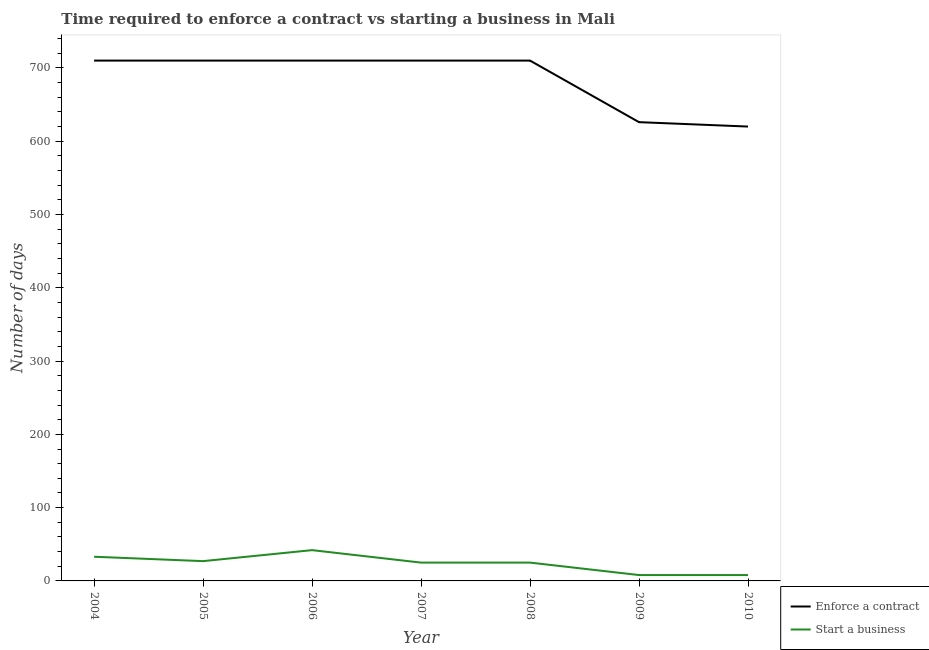Across all years, what is the maximum number of days to start a business?
Give a very brief answer. 42. In which year was the number of days to enforece a contract maximum?
Provide a succinct answer. 2004. In which year was the number of days to enforece a contract minimum?
Make the answer very short. 2010. What is the total number of days to start a business in the graph?
Your answer should be compact. 168. What is the difference between the number of days to start a business in 2004 and that in 2005?
Offer a terse response. 6. What is the difference between the number of days to start a business in 2005 and the number of days to enforece a contract in 2008?
Your response must be concise. -683. What is the average number of days to enforece a contract per year?
Offer a terse response. 685.14. In the year 2007, what is the difference between the number of days to start a business and number of days to enforece a contract?
Make the answer very short. -685. In how many years, is the number of days to enforece a contract greater than 360 days?
Keep it short and to the point. 7. What is the difference between the highest and the second highest number of days to enforece a contract?
Your response must be concise. 0. What is the difference between the highest and the lowest number of days to enforece a contract?
Offer a very short reply. 90. In how many years, is the number of days to enforece a contract greater than the average number of days to enforece a contract taken over all years?
Keep it short and to the point. 5. Is the number of days to start a business strictly greater than the number of days to enforece a contract over the years?
Provide a short and direct response. No. Is the number of days to start a business strictly less than the number of days to enforece a contract over the years?
Ensure brevity in your answer.  Yes. How many lines are there?
Your answer should be compact. 2. How many years are there in the graph?
Your response must be concise. 7. What is the difference between two consecutive major ticks on the Y-axis?
Your response must be concise. 100. Does the graph contain any zero values?
Ensure brevity in your answer.  No. How many legend labels are there?
Offer a very short reply. 2. How are the legend labels stacked?
Make the answer very short. Vertical. What is the title of the graph?
Your answer should be very brief. Time required to enforce a contract vs starting a business in Mali. What is the label or title of the X-axis?
Offer a very short reply. Year. What is the label or title of the Y-axis?
Ensure brevity in your answer.  Number of days. What is the Number of days of Enforce a contract in 2004?
Ensure brevity in your answer.  710. What is the Number of days of Enforce a contract in 2005?
Your answer should be very brief. 710. What is the Number of days of Start a business in 2005?
Offer a terse response. 27. What is the Number of days in Enforce a contract in 2006?
Provide a short and direct response. 710. What is the Number of days in Start a business in 2006?
Offer a terse response. 42. What is the Number of days in Enforce a contract in 2007?
Offer a very short reply. 710. What is the Number of days of Enforce a contract in 2008?
Provide a short and direct response. 710. What is the Number of days in Start a business in 2008?
Give a very brief answer. 25. What is the Number of days of Enforce a contract in 2009?
Provide a succinct answer. 626. What is the Number of days in Enforce a contract in 2010?
Provide a short and direct response. 620. What is the Number of days of Start a business in 2010?
Give a very brief answer. 8. Across all years, what is the maximum Number of days of Enforce a contract?
Ensure brevity in your answer.  710. Across all years, what is the maximum Number of days of Start a business?
Your answer should be compact. 42. Across all years, what is the minimum Number of days of Enforce a contract?
Ensure brevity in your answer.  620. What is the total Number of days in Enforce a contract in the graph?
Provide a short and direct response. 4796. What is the total Number of days of Start a business in the graph?
Keep it short and to the point. 168. What is the difference between the Number of days of Enforce a contract in 2004 and that in 2006?
Offer a terse response. 0. What is the difference between the Number of days in Start a business in 2004 and that in 2007?
Make the answer very short. 8. What is the difference between the Number of days in Start a business in 2004 and that in 2008?
Provide a succinct answer. 8. What is the difference between the Number of days in Enforce a contract in 2004 and that in 2009?
Give a very brief answer. 84. What is the difference between the Number of days in Start a business in 2004 and that in 2009?
Your answer should be compact. 25. What is the difference between the Number of days in Enforce a contract in 2004 and that in 2010?
Your answer should be compact. 90. What is the difference between the Number of days in Enforce a contract in 2005 and that in 2006?
Provide a succinct answer. 0. What is the difference between the Number of days of Start a business in 2005 and that in 2007?
Your answer should be compact. 2. What is the difference between the Number of days in Enforce a contract in 2005 and that in 2008?
Provide a succinct answer. 0. What is the difference between the Number of days in Start a business in 2005 and that in 2008?
Provide a short and direct response. 2. What is the difference between the Number of days of Start a business in 2005 and that in 2009?
Give a very brief answer. 19. What is the difference between the Number of days in Enforce a contract in 2006 and that in 2008?
Provide a succinct answer. 0. What is the difference between the Number of days of Start a business in 2006 and that in 2008?
Your answer should be compact. 17. What is the difference between the Number of days of Enforce a contract in 2006 and that in 2009?
Make the answer very short. 84. What is the difference between the Number of days of Enforce a contract in 2006 and that in 2010?
Your answer should be compact. 90. What is the difference between the Number of days of Enforce a contract in 2007 and that in 2008?
Offer a very short reply. 0. What is the difference between the Number of days in Start a business in 2007 and that in 2009?
Give a very brief answer. 17. What is the difference between the Number of days in Enforce a contract in 2007 and that in 2010?
Your answer should be compact. 90. What is the difference between the Number of days in Start a business in 2007 and that in 2010?
Provide a short and direct response. 17. What is the difference between the Number of days in Start a business in 2008 and that in 2009?
Offer a terse response. 17. What is the difference between the Number of days of Start a business in 2008 and that in 2010?
Make the answer very short. 17. What is the difference between the Number of days in Enforce a contract in 2004 and the Number of days in Start a business in 2005?
Your answer should be compact. 683. What is the difference between the Number of days in Enforce a contract in 2004 and the Number of days in Start a business in 2006?
Offer a terse response. 668. What is the difference between the Number of days of Enforce a contract in 2004 and the Number of days of Start a business in 2007?
Your answer should be very brief. 685. What is the difference between the Number of days of Enforce a contract in 2004 and the Number of days of Start a business in 2008?
Your response must be concise. 685. What is the difference between the Number of days of Enforce a contract in 2004 and the Number of days of Start a business in 2009?
Give a very brief answer. 702. What is the difference between the Number of days of Enforce a contract in 2004 and the Number of days of Start a business in 2010?
Ensure brevity in your answer.  702. What is the difference between the Number of days of Enforce a contract in 2005 and the Number of days of Start a business in 2006?
Your answer should be compact. 668. What is the difference between the Number of days in Enforce a contract in 2005 and the Number of days in Start a business in 2007?
Provide a short and direct response. 685. What is the difference between the Number of days in Enforce a contract in 2005 and the Number of days in Start a business in 2008?
Your answer should be very brief. 685. What is the difference between the Number of days of Enforce a contract in 2005 and the Number of days of Start a business in 2009?
Your response must be concise. 702. What is the difference between the Number of days in Enforce a contract in 2005 and the Number of days in Start a business in 2010?
Offer a very short reply. 702. What is the difference between the Number of days in Enforce a contract in 2006 and the Number of days in Start a business in 2007?
Your answer should be compact. 685. What is the difference between the Number of days of Enforce a contract in 2006 and the Number of days of Start a business in 2008?
Your answer should be very brief. 685. What is the difference between the Number of days in Enforce a contract in 2006 and the Number of days in Start a business in 2009?
Keep it short and to the point. 702. What is the difference between the Number of days in Enforce a contract in 2006 and the Number of days in Start a business in 2010?
Offer a terse response. 702. What is the difference between the Number of days of Enforce a contract in 2007 and the Number of days of Start a business in 2008?
Ensure brevity in your answer.  685. What is the difference between the Number of days in Enforce a contract in 2007 and the Number of days in Start a business in 2009?
Ensure brevity in your answer.  702. What is the difference between the Number of days of Enforce a contract in 2007 and the Number of days of Start a business in 2010?
Ensure brevity in your answer.  702. What is the difference between the Number of days in Enforce a contract in 2008 and the Number of days in Start a business in 2009?
Your answer should be compact. 702. What is the difference between the Number of days of Enforce a contract in 2008 and the Number of days of Start a business in 2010?
Offer a terse response. 702. What is the difference between the Number of days in Enforce a contract in 2009 and the Number of days in Start a business in 2010?
Offer a very short reply. 618. What is the average Number of days of Enforce a contract per year?
Your answer should be very brief. 685.14. What is the average Number of days of Start a business per year?
Provide a succinct answer. 24. In the year 2004, what is the difference between the Number of days in Enforce a contract and Number of days in Start a business?
Your response must be concise. 677. In the year 2005, what is the difference between the Number of days of Enforce a contract and Number of days of Start a business?
Make the answer very short. 683. In the year 2006, what is the difference between the Number of days in Enforce a contract and Number of days in Start a business?
Offer a terse response. 668. In the year 2007, what is the difference between the Number of days of Enforce a contract and Number of days of Start a business?
Provide a succinct answer. 685. In the year 2008, what is the difference between the Number of days in Enforce a contract and Number of days in Start a business?
Ensure brevity in your answer.  685. In the year 2009, what is the difference between the Number of days in Enforce a contract and Number of days in Start a business?
Offer a very short reply. 618. In the year 2010, what is the difference between the Number of days in Enforce a contract and Number of days in Start a business?
Your answer should be compact. 612. What is the ratio of the Number of days of Enforce a contract in 2004 to that in 2005?
Make the answer very short. 1. What is the ratio of the Number of days in Start a business in 2004 to that in 2005?
Offer a terse response. 1.22. What is the ratio of the Number of days of Start a business in 2004 to that in 2006?
Your answer should be compact. 0.79. What is the ratio of the Number of days of Start a business in 2004 to that in 2007?
Ensure brevity in your answer.  1.32. What is the ratio of the Number of days in Enforce a contract in 2004 to that in 2008?
Give a very brief answer. 1. What is the ratio of the Number of days in Start a business in 2004 to that in 2008?
Your answer should be very brief. 1.32. What is the ratio of the Number of days in Enforce a contract in 2004 to that in 2009?
Provide a succinct answer. 1.13. What is the ratio of the Number of days in Start a business in 2004 to that in 2009?
Give a very brief answer. 4.12. What is the ratio of the Number of days in Enforce a contract in 2004 to that in 2010?
Offer a very short reply. 1.15. What is the ratio of the Number of days in Start a business in 2004 to that in 2010?
Ensure brevity in your answer.  4.12. What is the ratio of the Number of days in Start a business in 2005 to that in 2006?
Ensure brevity in your answer.  0.64. What is the ratio of the Number of days of Enforce a contract in 2005 to that in 2007?
Make the answer very short. 1. What is the ratio of the Number of days in Start a business in 2005 to that in 2008?
Keep it short and to the point. 1.08. What is the ratio of the Number of days in Enforce a contract in 2005 to that in 2009?
Your response must be concise. 1.13. What is the ratio of the Number of days in Start a business in 2005 to that in 2009?
Give a very brief answer. 3.38. What is the ratio of the Number of days of Enforce a contract in 2005 to that in 2010?
Give a very brief answer. 1.15. What is the ratio of the Number of days in Start a business in 2005 to that in 2010?
Make the answer very short. 3.38. What is the ratio of the Number of days of Start a business in 2006 to that in 2007?
Give a very brief answer. 1.68. What is the ratio of the Number of days of Start a business in 2006 to that in 2008?
Keep it short and to the point. 1.68. What is the ratio of the Number of days of Enforce a contract in 2006 to that in 2009?
Provide a succinct answer. 1.13. What is the ratio of the Number of days in Start a business in 2006 to that in 2009?
Give a very brief answer. 5.25. What is the ratio of the Number of days in Enforce a contract in 2006 to that in 2010?
Offer a terse response. 1.15. What is the ratio of the Number of days in Start a business in 2006 to that in 2010?
Provide a succinct answer. 5.25. What is the ratio of the Number of days in Enforce a contract in 2007 to that in 2008?
Keep it short and to the point. 1. What is the ratio of the Number of days of Enforce a contract in 2007 to that in 2009?
Provide a succinct answer. 1.13. What is the ratio of the Number of days in Start a business in 2007 to that in 2009?
Offer a terse response. 3.12. What is the ratio of the Number of days of Enforce a contract in 2007 to that in 2010?
Offer a terse response. 1.15. What is the ratio of the Number of days of Start a business in 2007 to that in 2010?
Provide a succinct answer. 3.12. What is the ratio of the Number of days in Enforce a contract in 2008 to that in 2009?
Your answer should be very brief. 1.13. What is the ratio of the Number of days of Start a business in 2008 to that in 2009?
Provide a short and direct response. 3.12. What is the ratio of the Number of days of Enforce a contract in 2008 to that in 2010?
Provide a succinct answer. 1.15. What is the ratio of the Number of days in Start a business in 2008 to that in 2010?
Make the answer very short. 3.12. What is the ratio of the Number of days in Enforce a contract in 2009 to that in 2010?
Offer a very short reply. 1.01. What is the ratio of the Number of days in Start a business in 2009 to that in 2010?
Ensure brevity in your answer.  1. What is the difference between the highest and the second highest Number of days of Enforce a contract?
Ensure brevity in your answer.  0. What is the difference between the highest and the lowest Number of days of Enforce a contract?
Make the answer very short. 90. What is the difference between the highest and the lowest Number of days in Start a business?
Ensure brevity in your answer.  34. 